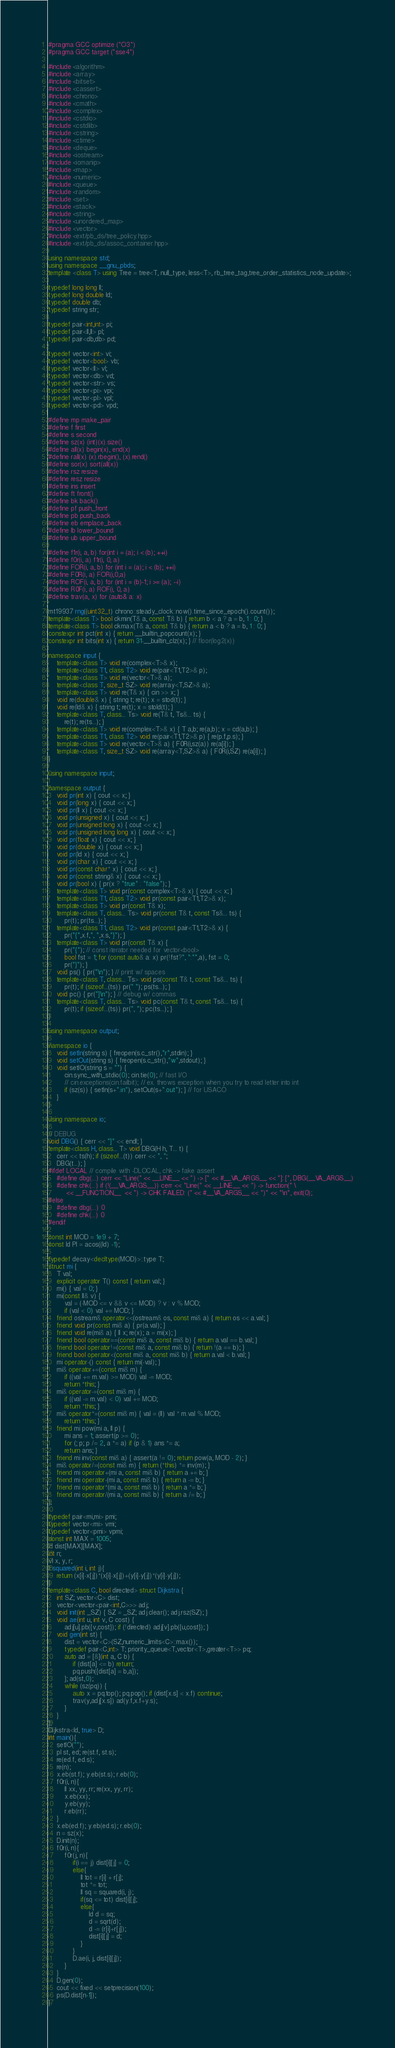<code> <loc_0><loc_0><loc_500><loc_500><_C++_>#pragma GCC optimize ("O3")
#pragma GCC target ("sse4")

#include <algorithm>
#include <array>
#include <bitset>
#include <cassert>
#include <chrono>
#include <cmath>
#include <complex>
#include <cstdio>
#include <cstdlib>
#include <cstring>
#include <ctime>
#include <deque>
#include <iostream>
#include <iomanip>
#include <map>
#include <numeric>
#include <queue>
#include <random>
#include <set>
#include <stack>
#include <string>
#include <unordered_map>
#include <vector>
#include <ext/pb_ds/tree_policy.hpp>
#include <ext/pb_ds/assoc_container.hpp>

using namespace std;
using namespace __gnu_pbds;
template <class T> using Tree = tree<T, null_type, less<T>, rb_tree_tag,tree_order_statistics_node_update>;

typedef long long ll;
typedef long double ld;
typedef double db;
typedef string str;

typedef pair<int,int> pi;
typedef pair<ll,ll> pl;
typedef pair<db,db> pd;

typedef vector<int> vi;
typedef vector<bool> vb;
typedef vector<ll> vl;
typedef vector<db> vd;
typedef vector<str> vs;
typedef vector<pi> vpi;
typedef vector<pl> vpl;
typedef vector<pd> vpd;

#define mp make_pair
#define f first
#define s second
#define sz(x) (int)(x).size()
#define all(x) begin(x), end(x)
#define rall(x) (x).rbegin(), (x).rend()
#define sor(x) sort(all(x))
#define rsz resize
#define resz resize
#define ins insert
#define ft front()
#define bk back()
#define pf push_front
#define pb push_back
#define eb emplace_back
#define lb lower_bound
#define ub upper_bound

#define f1r(i, a, b) for(int i = (a); i < (b); ++i)
#define f0r(i, a) f1r(i, 0, a)
#define FOR(i, a, b) for (int i = (a); i < (b); ++i)
#define F0R(i, a) FOR(i,0,a)
#define ROF(i, a, b) for (int i = (b)-1; i >= (a); --i)
#define R0F(i, a) ROF(i, 0, a)
#define trav(a, x) for (auto& a: x)

mt19937 rng((uint32_t) chrono::steady_clock::now().time_since_epoch().count());
template<class T> bool ckmin(T& a, const T& b) { return b < a ? a = b, 1 : 0; }
template<class T> bool ckmax(T& a, const T& b) { return a < b ? a = b, 1 : 0; }
constexpr int pct(int x) { return __builtin_popcount(x); }
constexpr int bits(int x) { return 31-__builtin_clz(x); } // floor(log2(x))

namespace input {
    template<class T> void re(complex<T>& x);
    template<class T1, class T2> void re(pair<T1,T2>& p);
    template<class T> void re(vector<T>& a);
    template<class T, size_t SZ> void re(array<T,SZ>& a);
    template<class T> void re(T& x) { cin >> x; }
    void re(double& x) { string t; re(t); x = stod(t); }
    void re(ld& x) { string t; re(t); x = stold(t); }
    template<class T, class... Ts> void re(T& t, Ts&... ts) {
        re(t); re(ts...); }
    template<class T> void re(complex<T>& x) { T a,b; re(a,b); x = cd(a,b); }
    template<class T1, class T2> void re(pair<T1,T2>& p) { re(p.f,p.s); }
    template<class T> void re(vector<T>& a) { F0R(i,sz(a)) re(a[i]); }
    template<class T, size_t SZ> void re(array<T,SZ>& a) { F0R(i,SZ) re(a[i]); }
}

using namespace input;

namespace output {
    void pr(int x) { cout << x; }
    void pr(long x) { cout << x; }
    void pr(ll x) { cout << x; }
    void pr(unsigned x) { cout << x; }
    void pr(unsigned long x) { cout << x; }
    void pr(unsigned long long x) { cout << x; }
    void pr(float x) { cout << x; }
    void pr(double x) { cout << x; }
    void pr(ld x) { cout << x; }
    void pr(char x) { cout << x; }
    void pr(const char* x) { cout << x; }
    void pr(const string& x) { cout << x; }
    void pr(bool x) { pr(x ? "true" : "false"); }
    template<class T> void pr(const complex<T>& x) { cout << x; }
    template<class T1, class T2> void pr(const pair<T1,T2>& x);
    template<class T> void pr(const T& x);
    template<class T, class... Ts> void pr(const T& t, const Ts&... ts) {
        pr(t); pr(ts...); }
    template<class T1, class T2> void pr(const pair<T1,T2>& x) {
        pr("{",x.f,", ",x.s,"}"); }
    template<class T> void pr(const T& x) {
        pr("{"); // const iterator needed for vector<bool>
        bool fst = 1; for (const auto& a: x) pr(!fst?", ":"",a), fst = 0;
        pr("}"); }
    void ps() { pr("\n"); } // print w/ spaces
    template<class T, class... Ts> void ps(const T& t, const Ts&... ts) {
        pr(t); if (sizeof...(ts)) pr(" "); ps(ts...); }
    void pc() { pr("]\n"); } // debug w/ commas
    template<class T, class... Ts> void pc(const T& t, const Ts&... ts) {
        pr(t); if (sizeof...(ts)) pr(", "); pc(ts...); }
}

using namespace output;

namespace io {
    void setIn(string s) { freopen(s.c_str(),"r",stdin); }
    void setOut(string s) { freopen(s.c_str(),"w",stdout); }
    void setIO(string s = "") {
        cin.sync_with_stdio(0); cin.tie(0); // fast I/O
        // cin.exceptions(cin.failbit); // ex. throws exception when you try to read letter into int
        if (sz(s)) { setIn(s+".in"), setOut(s+".out"); } // for USACO
    }
}

using namespace io;

// DEBUG
void DBG() { cerr << "]" << endl; }
template<class H, class... T> void DBG(H h, T... t) {
	cerr << ts(h); if (sizeof...(t)) cerr << ", ";
	DBG(t...); }
#ifdef LOCAL // compile with -DLOCAL, chk -> fake assert
	#define dbg(...) cerr << "Line(" << __LINE__ << ") -> [" << #__VA_ARGS__ << "]: [", DBG(__VA_ARGS__)
	#define chk(...) if (!(__VA_ARGS__)) cerr << "Line(" << __LINE__ << ") -> function(" \
		 << __FUNCTION__  << ") -> CHK FAILED: (" << #__VA_ARGS__ << ")" << "\n", exit(0);
#else
	#define dbg(...) 0
	#define chk(...) 0
#endif

const int MOD = 1e9 + 7;
const ld PI = acos((ld) -1);

typedef decay<decltype(MOD)>::type T;
struct mi {
    T val;
    explicit operator T() const { return val; }
    mi() { val = 0; }
    mi(const ll& v) {
        val = (-MOD <= v && v <= MOD) ? v : v % MOD;
        if (val < 0) val += MOD; }
    friend ostream& operator<<(ostream& os, const mi& a) { return os << a.val; }
    friend void pr(const mi& a) { pr(a.val); }
    friend void re(mi& a) { ll x; re(x); a = mi(x); }
    friend bool operator==(const mi& a, const mi& b) { return a.val == b.val; }
    friend bool operator!=(const mi& a, const mi& b) { return !(a == b); }
    friend bool operator<(const mi& a, const mi& b) { return a.val < b.val; }
    mi operator-() const { return mi(-val); }
    mi& operator+=(const mi& m) {
        if ((val += m.val) >= MOD) val -= MOD;
        return *this; }
    mi& operator-=(const mi& m) {
        if ((val -= m.val) < 0) val += MOD;
        return *this; }
    mi& operator*=(const mi& m) { val = (ll) val * m.val % MOD;
        return *this; }
    friend mi pow(mi a, ll p) {
        mi ans = 1; assert(p >= 0);
        for (; p; p /= 2, a *= a) if (p & 1) ans *= a;
        return ans; }
    friend mi inv(const mi& a) { assert(a != 0); return pow(a, MOD - 2); }
    mi& operator/=(const mi& m) { return (*this) *= inv(m); }
    friend mi operator+(mi a, const mi& b) { return a += b; }
    friend mi operator-(mi a, const mi& b) { return a -= b; }
    friend mi operator*(mi a, const mi& b) { return a *= b; }
    friend mi operator/(mi a, const mi& b) { return a /= b; }
};

typedef pair<mi,mi> pmi;
typedef vector<mi> vmi;
typedef vector<pmi> vpmi;
const int MAX = 1005;
ld dist[MAX][MAX];
int n;
vl x, y, r;
ll squared(int i, int j){
    return (x[i]-x[j])*(x[i]-x[j])+(y[i]-y[j])*(y[i]-y[j]);
}
template<class C, bool directed> struct Dijkstra {
	int SZ; vector<C> dist;
	vector<vector<pair<int,C>>> adj;
	void init(int _SZ) { SZ = _SZ; adj.clear(); adj.rsz(SZ); }
	void ae(int u, int v, C cost) {
		adj[u].pb({v,cost}); if (!directed) adj[v].pb({u,cost}); }
	void gen(int st) {
		dist = vector<C>(SZ,numeric_limits<C>::max());
		typedef pair<C,int> T; priority_queue<T,vector<T>,greater<T>> pq;
		auto ad = [&](int a, C b) {
			if (dist[a] <= b) return;
			pq.push({dist[a] = b,a});
		}; ad(st,0);
		while (sz(pq)) {
			auto x = pq.top(); pq.pop(); if (dist[x.s] < x.f) continue;
			trav(y,adj[x.s]) ad(y.f,x.f+y.s);
		}
	}
};
Dijkstra<ld, true> D;
int main(){
    setIO("");
    pl st, ed; re(st.f, st.s);
    re(ed.f, ed.s);
    re(n);
    x.eb(st.f); y.eb(st.s); r.eb(0);
    f0r(i, n){
        ll xx, yy, rr; re(xx, yy, rr);
        x.eb(xx);
        y.eb(yy);
        r.eb(rr);
    }
    x.eb(ed.f); y.eb(ed.s); r.eb(0);
    n = sz(x);
    D.init(n);
    f0r(i, n){
        f0r(j, n){
            if(i == j) dist[i][j] = 0;
            else{
                ll tot = r[i] + r[j];
                tot *= tot;
                ll sq = squared(i, j);
                if(sq <= tot) dist[i][j];
                else{
                    ld d = sq;
                    d = sqrt(d);
                    d -= (r[i]+r[j]);
                    dist[i][j] = d;
                }
            }
            D.ae(i, j, dist[i][j]);
        }
    }
    D.gen(0);
    cout << fixed << setprecision(100);
    ps(D.dist[n-1]);
}
</code> 